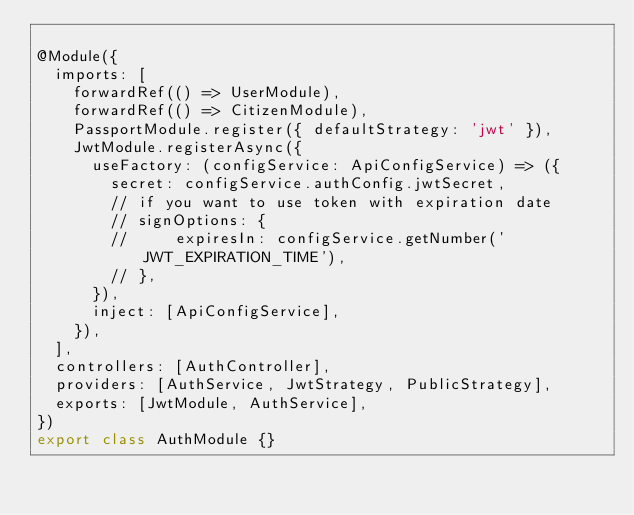<code> <loc_0><loc_0><loc_500><loc_500><_TypeScript_>
@Module({
  imports: [
    forwardRef(() => UserModule),
    forwardRef(() => CitizenModule),
    PassportModule.register({ defaultStrategy: 'jwt' }),
    JwtModule.registerAsync({
      useFactory: (configService: ApiConfigService) => ({
        secret: configService.authConfig.jwtSecret,
        // if you want to use token with expiration date
        // signOptions: {
        //     expiresIn: configService.getNumber('JWT_EXPIRATION_TIME'),
        // },
      }),
      inject: [ApiConfigService],
    }),
  ],
  controllers: [AuthController],
  providers: [AuthService, JwtStrategy, PublicStrategy],
  exports: [JwtModule, AuthService],
})
export class AuthModule {}
</code> 